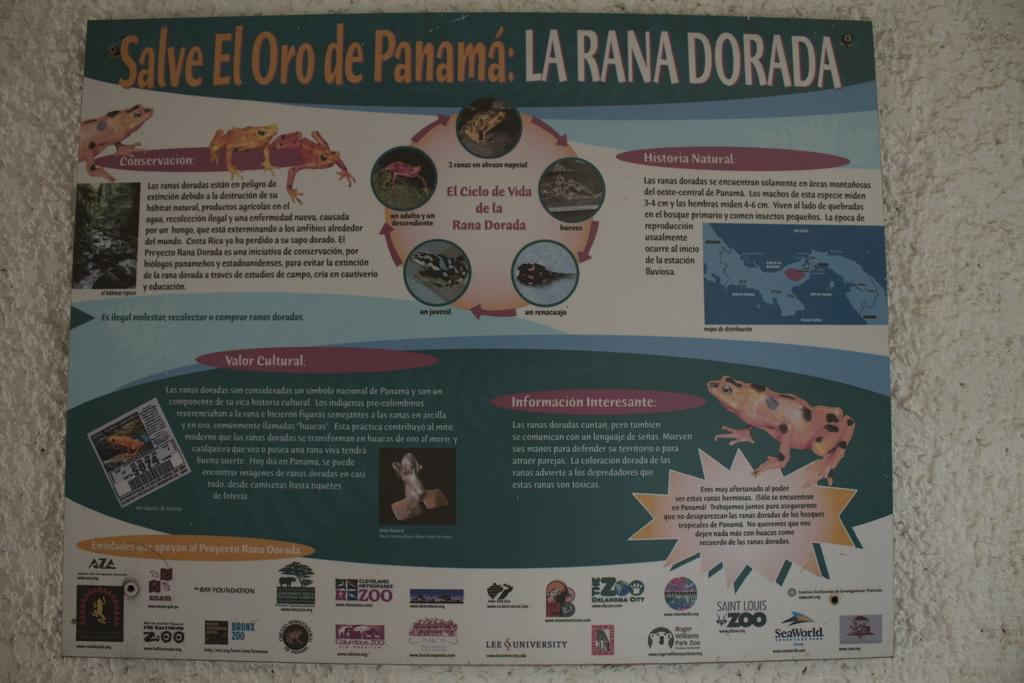<image>
Summarize the visual content of the image. A poster about the conservation efforts in Panama. 